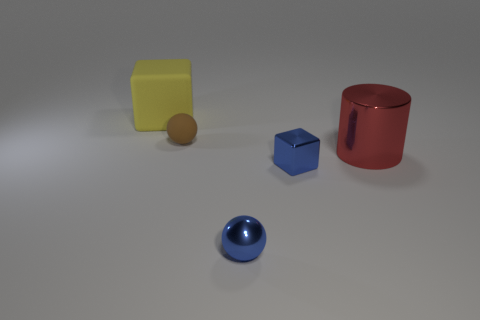Is there a small matte thing that has the same color as the big shiny cylinder?
Provide a succinct answer. No. Is there a brown object that has the same shape as the red object?
Give a very brief answer. No. There is a object that is behind the tiny blue sphere and in front of the red cylinder; what shape is it?
Make the answer very short. Cube. How many other balls have the same material as the blue sphere?
Your answer should be compact. 0. Are there fewer red shiny objects in front of the big block than blue metal things?
Your answer should be compact. Yes. There is a big thing in front of the big yellow thing; are there any big matte things right of it?
Provide a succinct answer. No. Is there anything else that is the same shape as the yellow matte object?
Your response must be concise. Yes. Does the cylinder have the same size as the rubber ball?
Offer a terse response. No. What material is the small ball that is behind the blue thing behind the ball in front of the big cylinder?
Provide a succinct answer. Rubber. Are there an equal number of tiny spheres that are right of the tiny blue cube and brown rubber cylinders?
Provide a succinct answer. Yes. 